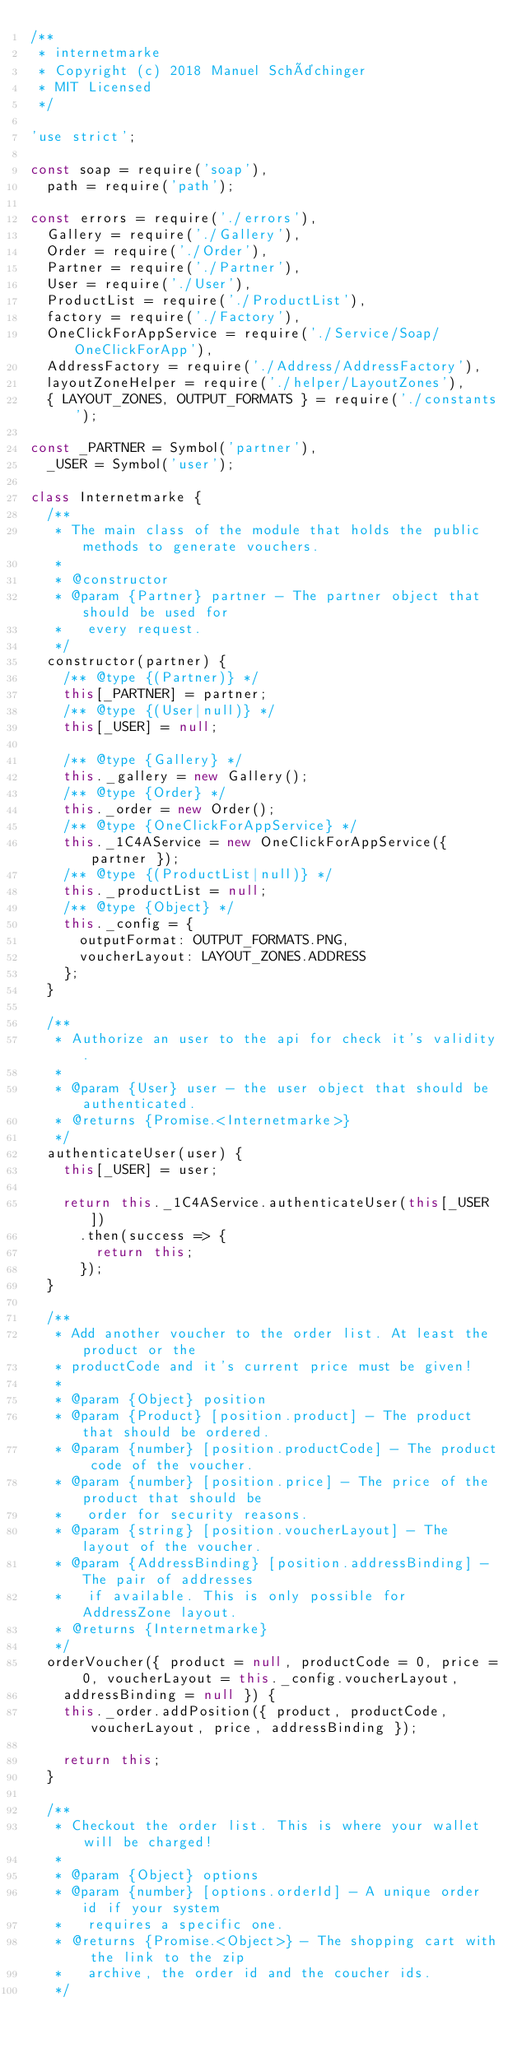Convert code to text. <code><loc_0><loc_0><loc_500><loc_500><_JavaScript_>/**
 * internetmarke
 * Copyright (c) 2018 Manuel Schächinger
 * MIT Licensed
 */

'use strict';

const soap = require('soap'),
  path = require('path');

const errors = require('./errors'),
  Gallery = require('./Gallery'),
  Order = require('./Order'),
  Partner = require('./Partner'),
  User = require('./User'),
  ProductList = require('./ProductList'),
  factory = require('./Factory'),
  OneClickForAppService = require('./Service/Soap/OneClickForApp'),
  AddressFactory = require('./Address/AddressFactory'),
  layoutZoneHelper = require('./helper/LayoutZones'),
  { LAYOUT_ZONES, OUTPUT_FORMATS } = require('./constants');

const _PARTNER = Symbol('partner'),
  _USER = Symbol('user');

class Internetmarke {
  /**
   * The main class of the module that holds the public methods to generate vouchers.
   * 
   * @constructor
   * @param {Partner} partner - The partner object that should be used for
   *   every request.
   */
  constructor(partner) {
    /** @type {(Partner)} */
    this[_PARTNER] = partner;
    /** @type {(User|null)} */
    this[_USER] = null;

    /** @type {Gallery} */
    this._gallery = new Gallery();
    /** @type {Order} */
    this._order = new Order();
    /** @type {OneClickForAppService} */
    this._1C4AService = new OneClickForAppService({ partner });
    /** @type {(ProductList|null)} */
    this._productList = null;
    /** @type {Object} */
    this._config = {
      outputFormat: OUTPUT_FORMATS.PNG,
      voucherLayout: LAYOUT_ZONES.ADDRESS
    };
  }

  /**
   * Authorize an user to the api for check it's validity.
   *
   * @param {User} user - the user object that should be authenticated.
   * @returns {Promise.<Internetmarke>}
   */
  authenticateUser(user) {
    this[_USER] = user;

    return this._1C4AService.authenticateUser(this[_USER])
      .then(success => {
        return this;
      });
  }

  /**
   * Add another voucher to the order list. At least the product or the
   * productCode and it's current price must be given!
   * 
   * @param {Object} position
   * @param {Product} [position.product] - The product that should be ordered.
   * @param {number} [position.productCode] - The product code of the voucher.
   * @param {number} [position.price] - The price of the product that should be
   *   order for security reasons.
   * @param {string} [position.voucherLayout] - The layout of the voucher.
   * @param {AddressBinding} [position.addressBinding] - The pair of addresses
   *   if available. This is only possible for AddressZone layout.
   * @returns {Internetmarke}
   */
  orderVoucher({ product = null, productCode = 0, price = 0, voucherLayout = this._config.voucherLayout,
    addressBinding = null }) {
    this._order.addPosition({ product, productCode, voucherLayout, price, addressBinding });

    return this;
  }

  /**
   * Checkout the order list. This is where your wallet will be charged!
   * 
   * @param {Object} options
   * @param {number} [options.orderId] - A unique order id if your system
   *   requires a specific one.
   * @returns {Promise.<Object>} - The shopping cart with the link to the zip
   *   archive, the order id and the coucher ids.
   */</code> 